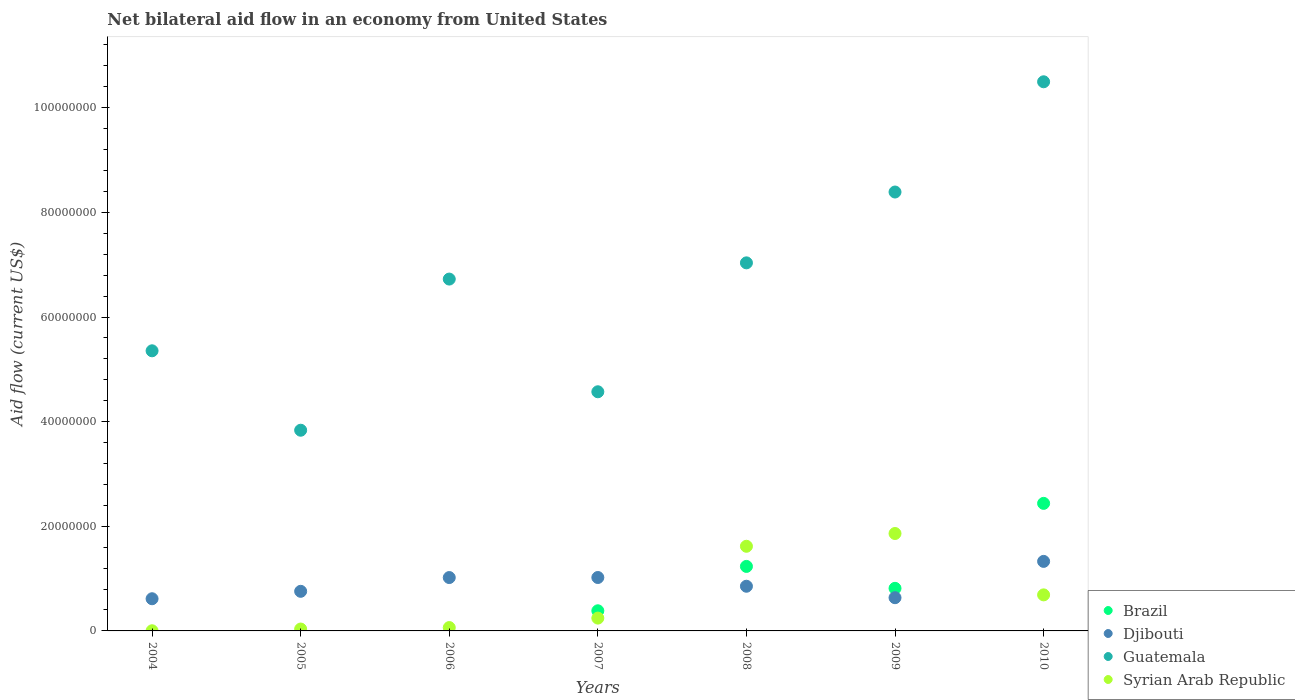Is the number of dotlines equal to the number of legend labels?
Keep it short and to the point. No. What is the net bilateral aid flow in Syrian Arab Republic in 2010?
Provide a succinct answer. 6.89e+06. Across all years, what is the maximum net bilateral aid flow in Syrian Arab Republic?
Your response must be concise. 1.86e+07. Across all years, what is the minimum net bilateral aid flow in Djibouti?
Keep it short and to the point. 6.15e+06. In which year was the net bilateral aid flow in Syrian Arab Republic maximum?
Your answer should be very brief. 2009. What is the total net bilateral aid flow in Syrian Arab Republic in the graph?
Give a very brief answer. 4.52e+07. What is the difference between the net bilateral aid flow in Djibouti in 2004 and that in 2010?
Keep it short and to the point. -7.14e+06. What is the difference between the net bilateral aid flow in Djibouti in 2006 and the net bilateral aid flow in Guatemala in 2009?
Ensure brevity in your answer.  -7.37e+07. What is the average net bilateral aid flow in Syrian Arab Republic per year?
Ensure brevity in your answer.  6.45e+06. In the year 2009, what is the difference between the net bilateral aid flow in Brazil and net bilateral aid flow in Syrian Arab Republic?
Give a very brief answer. -1.05e+07. In how many years, is the net bilateral aid flow in Syrian Arab Republic greater than 24000000 US$?
Your response must be concise. 0. What is the ratio of the net bilateral aid flow in Guatemala in 2006 to that in 2009?
Give a very brief answer. 0.8. What is the difference between the highest and the second highest net bilateral aid flow in Djibouti?
Offer a very short reply. 3.08e+06. What is the difference between the highest and the lowest net bilateral aid flow in Guatemala?
Provide a short and direct response. 6.66e+07. Is the sum of the net bilateral aid flow in Djibouti in 2006 and 2007 greater than the maximum net bilateral aid flow in Guatemala across all years?
Your answer should be very brief. No. Is it the case that in every year, the sum of the net bilateral aid flow in Guatemala and net bilateral aid flow in Syrian Arab Republic  is greater than the sum of net bilateral aid flow in Djibouti and net bilateral aid flow in Brazil?
Make the answer very short. Yes. Is it the case that in every year, the sum of the net bilateral aid flow in Djibouti and net bilateral aid flow in Brazil  is greater than the net bilateral aid flow in Guatemala?
Your response must be concise. No. Does the net bilateral aid flow in Djibouti monotonically increase over the years?
Keep it short and to the point. No. Is the net bilateral aid flow in Brazil strictly greater than the net bilateral aid flow in Djibouti over the years?
Provide a short and direct response. No. How many dotlines are there?
Keep it short and to the point. 4. Does the graph contain grids?
Make the answer very short. No. How are the legend labels stacked?
Ensure brevity in your answer.  Vertical. What is the title of the graph?
Make the answer very short. Net bilateral aid flow in an economy from United States. Does "Antigua and Barbuda" appear as one of the legend labels in the graph?
Provide a succinct answer. No. What is the Aid flow (current US$) in Djibouti in 2004?
Make the answer very short. 6.15e+06. What is the Aid flow (current US$) of Guatemala in 2004?
Provide a succinct answer. 5.35e+07. What is the Aid flow (current US$) in Djibouti in 2005?
Provide a succinct answer. 7.57e+06. What is the Aid flow (current US$) in Guatemala in 2005?
Your answer should be very brief. 3.84e+07. What is the Aid flow (current US$) in Brazil in 2006?
Ensure brevity in your answer.  0. What is the Aid flow (current US$) in Djibouti in 2006?
Your response must be concise. 1.02e+07. What is the Aid flow (current US$) in Guatemala in 2006?
Offer a very short reply. 6.72e+07. What is the Aid flow (current US$) of Syrian Arab Republic in 2006?
Provide a short and direct response. 6.40e+05. What is the Aid flow (current US$) in Brazil in 2007?
Make the answer very short. 3.85e+06. What is the Aid flow (current US$) of Djibouti in 2007?
Give a very brief answer. 1.02e+07. What is the Aid flow (current US$) in Guatemala in 2007?
Provide a succinct answer. 4.57e+07. What is the Aid flow (current US$) in Syrian Arab Republic in 2007?
Give a very brief answer. 2.45e+06. What is the Aid flow (current US$) of Brazil in 2008?
Offer a very short reply. 1.23e+07. What is the Aid flow (current US$) of Djibouti in 2008?
Your answer should be very brief. 8.54e+06. What is the Aid flow (current US$) of Guatemala in 2008?
Keep it short and to the point. 7.04e+07. What is the Aid flow (current US$) in Syrian Arab Republic in 2008?
Ensure brevity in your answer.  1.62e+07. What is the Aid flow (current US$) in Brazil in 2009?
Make the answer very short. 8.14e+06. What is the Aid flow (current US$) in Djibouti in 2009?
Keep it short and to the point. 6.35e+06. What is the Aid flow (current US$) in Guatemala in 2009?
Your answer should be very brief. 8.39e+07. What is the Aid flow (current US$) in Syrian Arab Republic in 2009?
Your answer should be compact. 1.86e+07. What is the Aid flow (current US$) in Brazil in 2010?
Give a very brief answer. 2.44e+07. What is the Aid flow (current US$) of Djibouti in 2010?
Provide a succinct answer. 1.33e+07. What is the Aid flow (current US$) in Guatemala in 2010?
Your response must be concise. 1.05e+08. What is the Aid flow (current US$) in Syrian Arab Republic in 2010?
Provide a short and direct response. 6.89e+06. Across all years, what is the maximum Aid flow (current US$) in Brazil?
Give a very brief answer. 2.44e+07. Across all years, what is the maximum Aid flow (current US$) of Djibouti?
Make the answer very short. 1.33e+07. Across all years, what is the maximum Aid flow (current US$) in Guatemala?
Provide a short and direct response. 1.05e+08. Across all years, what is the maximum Aid flow (current US$) of Syrian Arab Republic?
Your answer should be very brief. 1.86e+07. Across all years, what is the minimum Aid flow (current US$) in Brazil?
Give a very brief answer. 0. Across all years, what is the minimum Aid flow (current US$) of Djibouti?
Provide a succinct answer. 6.15e+06. Across all years, what is the minimum Aid flow (current US$) of Guatemala?
Make the answer very short. 3.84e+07. What is the total Aid flow (current US$) of Brazil in the graph?
Ensure brevity in your answer.  4.87e+07. What is the total Aid flow (current US$) of Djibouti in the graph?
Keep it short and to the point. 6.23e+07. What is the total Aid flow (current US$) in Guatemala in the graph?
Provide a succinct answer. 4.64e+08. What is the total Aid flow (current US$) in Syrian Arab Republic in the graph?
Keep it short and to the point. 4.52e+07. What is the difference between the Aid flow (current US$) in Djibouti in 2004 and that in 2005?
Your answer should be very brief. -1.42e+06. What is the difference between the Aid flow (current US$) of Guatemala in 2004 and that in 2005?
Provide a succinct answer. 1.52e+07. What is the difference between the Aid flow (current US$) in Syrian Arab Republic in 2004 and that in 2005?
Keep it short and to the point. -3.30e+05. What is the difference between the Aid flow (current US$) in Djibouti in 2004 and that in 2006?
Provide a succinct answer. -4.05e+06. What is the difference between the Aid flow (current US$) of Guatemala in 2004 and that in 2006?
Provide a short and direct response. -1.37e+07. What is the difference between the Aid flow (current US$) of Syrian Arab Republic in 2004 and that in 2006?
Give a very brief answer. -6.10e+05. What is the difference between the Aid flow (current US$) in Djibouti in 2004 and that in 2007?
Keep it short and to the point. -4.06e+06. What is the difference between the Aid flow (current US$) in Guatemala in 2004 and that in 2007?
Your answer should be compact. 7.83e+06. What is the difference between the Aid flow (current US$) in Syrian Arab Republic in 2004 and that in 2007?
Your answer should be compact. -2.42e+06. What is the difference between the Aid flow (current US$) of Djibouti in 2004 and that in 2008?
Provide a short and direct response. -2.39e+06. What is the difference between the Aid flow (current US$) in Guatemala in 2004 and that in 2008?
Ensure brevity in your answer.  -1.68e+07. What is the difference between the Aid flow (current US$) in Syrian Arab Republic in 2004 and that in 2008?
Your answer should be very brief. -1.62e+07. What is the difference between the Aid flow (current US$) in Guatemala in 2004 and that in 2009?
Ensure brevity in your answer.  -3.04e+07. What is the difference between the Aid flow (current US$) in Syrian Arab Republic in 2004 and that in 2009?
Provide a succinct answer. -1.86e+07. What is the difference between the Aid flow (current US$) of Djibouti in 2004 and that in 2010?
Your response must be concise. -7.14e+06. What is the difference between the Aid flow (current US$) in Guatemala in 2004 and that in 2010?
Ensure brevity in your answer.  -5.14e+07. What is the difference between the Aid flow (current US$) in Syrian Arab Republic in 2004 and that in 2010?
Ensure brevity in your answer.  -6.86e+06. What is the difference between the Aid flow (current US$) in Djibouti in 2005 and that in 2006?
Make the answer very short. -2.63e+06. What is the difference between the Aid flow (current US$) of Guatemala in 2005 and that in 2006?
Ensure brevity in your answer.  -2.89e+07. What is the difference between the Aid flow (current US$) of Syrian Arab Republic in 2005 and that in 2006?
Offer a terse response. -2.80e+05. What is the difference between the Aid flow (current US$) of Djibouti in 2005 and that in 2007?
Your answer should be compact. -2.64e+06. What is the difference between the Aid flow (current US$) of Guatemala in 2005 and that in 2007?
Provide a short and direct response. -7.35e+06. What is the difference between the Aid flow (current US$) in Syrian Arab Republic in 2005 and that in 2007?
Give a very brief answer. -2.09e+06. What is the difference between the Aid flow (current US$) in Djibouti in 2005 and that in 2008?
Ensure brevity in your answer.  -9.70e+05. What is the difference between the Aid flow (current US$) of Guatemala in 2005 and that in 2008?
Provide a succinct answer. -3.20e+07. What is the difference between the Aid flow (current US$) of Syrian Arab Republic in 2005 and that in 2008?
Your answer should be very brief. -1.58e+07. What is the difference between the Aid flow (current US$) in Djibouti in 2005 and that in 2009?
Provide a short and direct response. 1.22e+06. What is the difference between the Aid flow (current US$) of Guatemala in 2005 and that in 2009?
Your answer should be very brief. -4.55e+07. What is the difference between the Aid flow (current US$) in Syrian Arab Republic in 2005 and that in 2009?
Ensure brevity in your answer.  -1.83e+07. What is the difference between the Aid flow (current US$) in Djibouti in 2005 and that in 2010?
Your response must be concise. -5.72e+06. What is the difference between the Aid flow (current US$) of Guatemala in 2005 and that in 2010?
Provide a short and direct response. -6.66e+07. What is the difference between the Aid flow (current US$) in Syrian Arab Republic in 2005 and that in 2010?
Your answer should be very brief. -6.53e+06. What is the difference between the Aid flow (current US$) in Djibouti in 2006 and that in 2007?
Provide a succinct answer. -10000. What is the difference between the Aid flow (current US$) in Guatemala in 2006 and that in 2007?
Provide a short and direct response. 2.15e+07. What is the difference between the Aid flow (current US$) of Syrian Arab Republic in 2006 and that in 2007?
Your response must be concise. -1.81e+06. What is the difference between the Aid flow (current US$) of Djibouti in 2006 and that in 2008?
Provide a short and direct response. 1.66e+06. What is the difference between the Aid flow (current US$) in Guatemala in 2006 and that in 2008?
Offer a very short reply. -3.10e+06. What is the difference between the Aid flow (current US$) of Syrian Arab Republic in 2006 and that in 2008?
Offer a very short reply. -1.55e+07. What is the difference between the Aid flow (current US$) of Djibouti in 2006 and that in 2009?
Your answer should be compact. 3.85e+06. What is the difference between the Aid flow (current US$) in Guatemala in 2006 and that in 2009?
Keep it short and to the point. -1.66e+07. What is the difference between the Aid flow (current US$) of Syrian Arab Republic in 2006 and that in 2009?
Make the answer very short. -1.80e+07. What is the difference between the Aid flow (current US$) in Djibouti in 2006 and that in 2010?
Give a very brief answer. -3.09e+06. What is the difference between the Aid flow (current US$) in Guatemala in 2006 and that in 2010?
Your response must be concise. -3.77e+07. What is the difference between the Aid flow (current US$) in Syrian Arab Republic in 2006 and that in 2010?
Your response must be concise. -6.25e+06. What is the difference between the Aid flow (current US$) of Brazil in 2007 and that in 2008?
Provide a succinct answer. -8.48e+06. What is the difference between the Aid flow (current US$) of Djibouti in 2007 and that in 2008?
Your answer should be compact. 1.67e+06. What is the difference between the Aid flow (current US$) in Guatemala in 2007 and that in 2008?
Your response must be concise. -2.46e+07. What is the difference between the Aid flow (current US$) of Syrian Arab Republic in 2007 and that in 2008?
Give a very brief answer. -1.37e+07. What is the difference between the Aid flow (current US$) in Brazil in 2007 and that in 2009?
Offer a terse response. -4.29e+06. What is the difference between the Aid flow (current US$) in Djibouti in 2007 and that in 2009?
Give a very brief answer. 3.86e+06. What is the difference between the Aid flow (current US$) in Guatemala in 2007 and that in 2009?
Make the answer very short. -3.82e+07. What is the difference between the Aid flow (current US$) in Syrian Arab Republic in 2007 and that in 2009?
Offer a very short reply. -1.62e+07. What is the difference between the Aid flow (current US$) of Brazil in 2007 and that in 2010?
Ensure brevity in your answer.  -2.05e+07. What is the difference between the Aid flow (current US$) of Djibouti in 2007 and that in 2010?
Your response must be concise. -3.08e+06. What is the difference between the Aid flow (current US$) in Guatemala in 2007 and that in 2010?
Ensure brevity in your answer.  -5.92e+07. What is the difference between the Aid flow (current US$) of Syrian Arab Republic in 2007 and that in 2010?
Ensure brevity in your answer.  -4.44e+06. What is the difference between the Aid flow (current US$) in Brazil in 2008 and that in 2009?
Offer a terse response. 4.19e+06. What is the difference between the Aid flow (current US$) in Djibouti in 2008 and that in 2009?
Provide a succinct answer. 2.19e+06. What is the difference between the Aid flow (current US$) of Guatemala in 2008 and that in 2009?
Ensure brevity in your answer.  -1.35e+07. What is the difference between the Aid flow (current US$) of Syrian Arab Republic in 2008 and that in 2009?
Offer a very short reply. -2.44e+06. What is the difference between the Aid flow (current US$) in Brazil in 2008 and that in 2010?
Your response must be concise. -1.20e+07. What is the difference between the Aid flow (current US$) in Djibouti in 2008 and that in 2010?
Your response must be concise. -4.75e+06. What is the difference between the Aid flow (current US$) of Guatemala in 2008 and that in 2010?
Your response must be concise. -3.46e+07. What is the difference between the Aid flow (current US$) of Syrian Arab Republic in 2008 and that in 2010?
Make the answer very short. 9.29e+06. What is the difference between the Aid flow (current US$) in Brazil in 2009 and that in 2010?
Offer a terse response. -1.62e+07. What is the difference between the Aid flow (current US$) of Djibouti in 2009 and that in 2010?
Offer a very short reply. -6.94e+06. What is the difference between the Aid flow (current US$) of Guatemala in 2009 and that in 2010?
Your response must be concise. -2.11e+07. What is the difference between the Aid flow (current US$) in Syrian Arab Republic in 2009 and that in 2010?
Give a very brief answer. 1.17e+07. What is the difference between the Aid flow (current US$) in Djibouti in 2004 and the Aid flow (current US$) in Guatemala in 2005?
Offer a terse response. -3.22e+07. What is the difference between the Aid flow (current US$) in Djibouti in 2004 and the Aid flow (current US$) in Syrian Arab Republic in 2005?
Provide a succinct answer. 5.79e+06. What is the difference between the Aid flow (current US$) in Guatemala in 2004 and the Aid flow (current US$) in Syrian Arab Republic in 2005?
Your answer should be very brief. 5.32e+07. What is the difference between the Aid flow (current US$) in Djibouti in 2004 and the Aid flow (current US$) in Guatemala in 2006?
Make the answer very short. -6.11e+07. What is the difference between the Aid flow (current US$) of Djibouti in 2004 and the Aid flow (current US$) of Syrian Arab Republic in 2006?
Keep it short and to the point. 5.51e+06. What is the difference between the Aid flow (current US$) of Guatemala in 2004 and the Aid flow (current US$) of Syrian Arab Republic in 2006?
Provide a succinct answer. 5.29e+07. What is the difference between the Aid flow (current US$) in Djibouti in 2004 and the Aid flow (current US$) in Guatemala in 2007?
Give a very brief answer. -3.96e+07. What is the difference between the Aid flow (current US$) of Djibouti in 2004 and the Aid flow (current US$) of Syrian Arab Republic in 2007?
Provide a short and direct response. 3.70e+06. What is the difference between the Aid flow (current US$) in Guatemala in 2004 and the Aid flow (current US$) in Syrian Arab Republic in 2007?
Provide a succinct answer. 5.11e+07. What is the difference between the Aid flow (current US$) of Djibouti in 2004 and the Aid flow (current US$) of Guatemala in 2008?
Keep it short and to the point. -6.42e+07. What is the difference between the Aid flow (current US$) of Djibouti in 2004 and the Aid flow (current US$) of Syrian Arab Republic in 2008?
Offer a very short reply. -1.00e+07. What is the difference between the Aid flow (current US$) of Guatemala in 2004 and the Aid flow (current US$) of Syrian Arab Republic in 2008?
Offer a very short reply. 3.74e+07. What is the difference between the Aid flow (current US$) in Djibouti in 2004 and the Aid flow (current US$) in Guatemala in 2009?
Your answer should be compact. -7.77e+07. What is the difference between the Aid flow (current US$) in Djibouti in 2004 and the Aid flow (current US$) in Syrian Arab Republic in 2009?
Your response must be concise. -1.25e+07. What is the difference between the Aid flow (current US$) in Guatemala in 2004 and the Aid flow (current US$) in Syrian Arab Republic in 2009?
Provide a short and direct response. 3.49e+07. What is the difference between the Aid flow (current US$) of Djibouti in 2004 and the Aid flow (current US$) of Guatemala in 2010?
Ensure brevity in your answer.  -9.88e+07. What is the difference between the Aid flow (current US$) of Djibouti in 2004 and the Aid flow (current US$) of Syrian Arab Republic in 2010?
Keep it short and to the point. -7.40e+05. What is the difference between the Aid flow (current US$) of Guatemala in 2004 and the Aid flow (current US$) of Syrian Arab Republic in 2010?
Provide a succinct answer. 4.66e+07. What is the difference between the Aid flow (current US$) in Djibouti in 2005 and the Aid flow (current US$) in Guatemala in 2006?
Give a very brief answer. -5.97e+07. What is the difference between the Aid flow (current US$) of Djibouti in 2005 and the Aid flow (current US$) of Syrian Arab Republic in 2006?
Offer a very short reply. 6.93e+06. What is the difference between the Aid flow (current US$) in Guatemala in 2005 and the Aid flow (current US$) in Syrian Arab Republic in 2006?
Ensure brevity in your answer.  3.77e+07. What is the difference between the Aid flow (current US$) in Djibouti in 2005 and the Aid flow (current US$) in Guatemala in 2007?
Provide a short and direct response. -3.81e+07. What is the difference between the Aid flow (current US$) in Djibouti in 2005 and the Aid flow (current US$) in Syrian Arab Republic in 2007?
Ensure brevity in your answer.  5.12e+06. What is the difference between the Aid flow (current US$) in Guatemala in 2005 and the Aid flow (current US$) in Syrian Arab Republic in 2007?
Ensure brevity in your answer.  3.59e+07. What is the difference between the Aid flow (current US$) of Djibouti in 2005 and the Aid flow (current US$) of Guatemala in 2008?
Keep it short and to the point. -6.28e+07. What is the difference between the Aid flow (current US$) in Djibouti in 2005 and the Aid flow (current US$) in Syrian Arab Republic in 2008?
Offer a terse response. -8.61e+06. What is the difference between the Aid flow (current US$) of Guatemala in 2005 and the Aid flow (current US$) of Syrian Arab Republic in 2008?
Offer a terse response. 2.22e+07. What is the difference between the Aid flow (current US$) in Djibouti in 2005 and the Aid flow (current US$) in Guatemala in 2009?
Offer a terse response. -7.63e+07. What is the difference between the Aid flow (current US$) in Djibouti in 2005 and the Aid flow (current US$) in Syrian Arab Republic in 2009?
Your answer should be compact. -1.10e+07. What is the difference between the Aid flow (current US$) in Guatemala in 2005 and the Aid flow (current US$) in Syrian Arab Republic in 2009?
Offer a very short reply. 1.97e+07. What is the difference between the Aid flow (current US$) of Djibouti in 2005 and the Aid flow (current US$) of Guatemala in 2010?
Give a very brief answer. -9.74e+07. What is the difference between the Aid flow (current US$) in Djibouti in 2005 and the Aid flow (current US$) in Syrian Arab Republic in 2010?
Keep it short and to the point. 6.80e+05. What is the difference between the Aid flow (current US$) of Guatemala in 2005 and the Aid flow (current US$) of Syrian Arab Republic in 2010?
Provide a succinct answer. 3.15e+07. What is the difference between the Aid flow (current US$) in Djibouti in 2006 and the Aid flow (current US$) in Guatemala in 2007?
Your response must be concise. -3.55e+07. What is the difference between the Aid flow (current US$) in Djibouti in 2006 and the Aid flow (current US$) in Syrian Arab Republic in 2007?
Your answer should be compact. 7.75e+06. What is the difference between the Aid flow (current US$) of Guatemala in 2006 and the Aid flow (current US$) of Syrian Arab Republic in 2007?
Ensure brevity in your answer.  6.48e+07. What is the difference between the Aid flow (current US$) of Djibouti in 2006 and the Aid flow (current US$) of Guatemala in 2008?
Make the answer very short. -6.02e+07. What is the difference between the Aid flow (current US$) in Djibouti in 2006 and the Aid flow (current US$) in Syrian Arab Republic in 2008?
Your answer should be very brief. -5.98e+06. What is the difference between the Aid flow (current US$) in Guatemala in 2006 and the Aid flow (current US$) in Syrian Arab Republic in 2008?
Ensure brevity in your answer.  5.11e+07. What is the difference between the Aid flow (current US$) of Djibouti in 2006 and the Aid flow (current US$) of Guatemala in 2009?
Offer a very short reply. -7.37e+07. What is the difference between the Aid flow (current US$) of Djibouti in 2006 and the Aid flow (current US$) of Syrian Arab Republic in 2009?
Make the answer very short. -8.42e+06. What is the difference between the Aid flow (current US$) of Guatemala in 2006 and the Aid flow (current US$) of Syrian Arab Republic in 2009?
Keep it short and to the point. 4.86e+07. What is the difference between the Aid flow (current US$) in Djibouti in 2006 and the Aid flow (current US$) in Guatemala in 2010?
Provide a short and direct response. -9.48e+07. What is the difference between the Aid flow (current US$) in Djibouti in 2006 and the Aid flow (current US$) in Syrian Arab Republic in 2010?
Provide a succinct answer. 3.31e+06. What is the difference between the Aid flow (current US$) of Guatemala in 2006 and the Aid flow (current US$) of Syrian Arab Republic in 2010?
Give a very brief answer. 6.04e+07. What is the difference between the Aid flow (current US$) of Brazil in 2007 and the Aid flow (current US$) of Djibouti in 2008?
Your answer should be compact. -4.69e+06. What is the difference between the Aid flow (current US$) of Brazil in 2007 and the Aid flow (current US$) of Guatemala in 2008?
Make the answer very short. -6.65e+07. What is the difference between the Aid flow (current US$) in Brazil in 2007 and the Aid flow (current US$) in Syrian Arab Republic in 2008?
Offer a very short reply. -1.23e+07. What is the difference between the Aid flow (current US$) in Djibouti in 2007 and the Aid flow (current US$) in Guatemala in 2008?
Your answer should be compact. -6.01e+07. What is the difference between the Aid flow (current US$) of Djibouti in 2007 and the Aid flow (current US$) of Syrian Arab Republic in 2008?
Make the answer very short. -5.97e+06. What is the difference between the Aid flow (current US$) in Guatemala in 2007 and the Aid flow (current US$) in Syrian Arab Republic in 2008?
Ensure brevity in your answer.  2.95e+07. What is the difference between the Aid flow (current US$) in Brazil in 2007 and the Aid flow (current US$) in Djibouti in 2009?
Provide a short and direct response. -2.50e+06. What is the difference between the Aid flow (current US$) in Brazil in 2007 and the Aid flow (current US$) in Guatemala in 2009?
Give a very brief answer. -8.00e+07. What is the difference between the Aid flow (current US$) in Brazil in 2007 and the Aid flow (current US$) in Syrian Arab Republic in 2009?
Your answer should be compact. -1.48e+07. What is the difference between the Aid flow (current US$) of Djibouti in 2007 and the Aid flow (current US$) of Guatemala in 2009?
Your answer should be compact. -7.37e+07. What is the difference between the Aid flow (current US$) in Djibouti in 2007 and the Aid flow (current US$) in Syrian Arab Republic in 2009?
Offer a terse response. -8.41e+06. What is the difference between the Aid flow (current US$) of Guatemala in 2007 and the Aid flow (current US$) of Syrian Arab Republic in 2009?
Offer a terse response. 2.71e+07. What is the difference between the Aid flow (current US$) of Brazil in 2007 and the Aid flow (current US$) of Djibouti in 2010?
Ensure brevity in your answer.  -9.44e+06. What is the difference between the Aid flow (current US$) in Brazil in 2007 and the Aid flow (current US$) in Guatemala in 2010?
Your answer should be compact. -1.01e+08. What is the difference between the Aid flow (current US$) of Brazil in 2007 and the Aid flow (current US$) of Syrian Arab Republic in 2010?
Your answer should be very brief. -3.04e+06. What is the difference between the Aid flow (current US$) in Djibouti in 2007 and the Aid flow (current US$) in Guatemala in 2010?
Your answer should be very brief. -9.48e+07. What is the difference between the Aid flow (current US$) of Djibouti in 2007 and the Aid flow (current US$) of Syrian Arab Republic in 2010?
Make the answer very short. 3.32e+06. What is the difference between the Aid flow (current US$) of Guatemala in 2007 and the Aid flow (current US$) of Syrian Arab Republic in 2010?
Offer a very short reply. 3.88e+07. What is the difference between the Aid flow (current US$) in Brazil in 2008 and the Aid flow (current US$) in Djibouti in 2009?
Keep it short and to the point. 5.98e+06. What is the difference between the Aid flow (current US$) in Brazil in 2008 and the Aid flow (current US$) in Guatemala in 2009?
Offer a terse response. -7.16e+07. What is the difference between the Aid flow (current US$) of Brazil in 2008 and the Aid flow (current US$) of Syrian Arab Republic in 2009?
Keep it short and to the point. -6.29e+06. What is the difference between the Aid flow (current US$) in Djibouti in 2008 and the Aid flow (current US$) in Guatemala in 2009?
Ensure brevity in your answer.  -7.54e+07. What is the difference between the Aid flow (current US$) in Djibouti in 2008 and the Aid flow (current US$) in Syrian Arab Republic in 2009?
Give a very brief answer. -1.01e+07. What is the difference between the Aid flow (current US$) of Guatemala in 2008 and the Aid flow (current US$) of Syrian Arab Republic in 2009?
Keep it short and to the point. 5.17e+07. What is the difference between the Aid flow (current US$) of Brazil in 2008 and the Aid flow (current US$) of Djibouti in 2010?
Your response must be concise. -9.60e+05. What is the difference between the Aid flow (current US$) of Brazil in 2008 and the Aid flow (current US$) of Guatemala in 2010?
Provide a succinct answer. -9.26e+07. What is the difference between the Aid flow (current US$) of Brazil in 2008 and the Aid flow (current US$) of Syrian Arab Republic in 2010?
Make the answer very short. 5.44e+06. What is the difference between the Aid flow (current US$) in Djibouti in 2008 and the Aid flow (current US$) in Guatemala in 2010?
Keep it short and to the point. -9.64e+07. What is the difference between the Aid flow (current US$) of Djibouti in 2008 and the Aid flow (current US$) of Syrian Arab Republic in 2010?
Your answer should be compact. 1.65e+06. What is the difference between the Aid flow (current US$) of Guatemala in 2008 and the Aid flow (current US$) of Syrian Arab Republic in 2010?
Provide a succinct answer. 6.35e+07. What is the difference between the Aid flow (current US$) of Brazil in 2009 and the Aid flow (current US$) of Djibouti in 2010?
Offer a terse response. -5.15e+06. What is the difference between the Aid flow (current US$) in Brazil in 2009 and the Aid flow (current US$) in Guatemala in 2010?
Give a very brief answer. -9.68e+07. What is the difference between the Aid flow (current US$) in Brazil in 2009 and the Aid flow (current US$) in Syrian Arab Republic in 2010?
Give a very brief answer. 1.25e+06. What is the difference between the Aid flow (current US$) in Djibouti in 2009 and the Aid flow (current US$) in Guatemala in 2010?
Your response must be concise. -9.86e+07. What is the difference between the Aid flow (current US$) of Djibouti in 2009 and the Aid flow (current US$) of Syrian Arab Republic in 2010?
Make the answer very short. -5.40e+05. What is the difference between the Aid flow (current US$) in Guatemala in 2009 and the Aid flow (current US$) in Syrian Arab Republic in 2010?
Give a very brief answer. 7.70e+07. What is the average Aid flow (current US$) in Brazil per year?
Your answer should be compact. 6.96e+06. What is the average Aid flow (current US$) of Djibouti per year?
Give a very brief answer. 8.90e+06. What is the average Aid flow (current US$) of Guatemala per year?
Provide a short and direct response. 6.63e+07. What is the average Aid flow (current US$) in Syrian Arab Republic per year?
Give a very brief answer. 6.45e+06. In the year 2004, what is the difference between the Aid flow (current US$) in Djibouti and Aid flow (current US$) in Guatemala?
Ensure brevity in your answer.  -4.74e+07. In the year 2004, what is the difference between the Aid flow (current US$) of Djibouti and Aid flow (current US$) of Syrian Arab Republic?
Offer a very short reply. 6.12e+06. In the year 2004, what is the difference between the Aid flow (current US$) of Guatemala and Aid flow (current US$) of Syrian Arab Republic?
Offer a terse response. 5.35e+07. In the year 2005, what is the difference between the Aid flow (current US$) of Djibouti and Aid flow (current US$) of Guatemala?
Ensure brevity in your answer.  -3.08e+07. In the year 2005, what is the difference between the Aid flow (current US$) of Djibouti and Aid flow (current US$) of Syrian Arab Republic?
Your answer should be very brief. 7.21e+06. In the year 2005, what is the difference between the Aid flow (current US$) in Guatemala and Aid flow (current US$) in Syrian Arab Republic?
Make the answer very short. 3.80e+07. In the year 2006, what is the difference between the Aid flow (current US$) of Djibouti and Aid flow (current US$) of Guatemala?
Your answer should be compact. -5.70e+07. In the year 2006, what is the difference between the Aid flow (current US$) in Djibouti and Aid flow (current US$) in Syrian Arab Republic?
Give a very brief answer. 9.56e+06. In the year 2006, what is the difference between the Aid flow (current US$) in Guatemala and Aid flow (current US$) in Syrian Arab Republic?
Provide a short and direct response. 6.66e+07. In the year 2007, what is the difference between the Aid flow (current US$) of Brazil and Aid flow (current US$) of Djibouti?
Offer a terse response. -6.36e+06. In the year 2007, what is the difference between the Aid flow (current US$) in Brazil and Aid flow (current US$) in Guatemala?
Provide a succinct answer. -4.19e+07. In the year 2007, what is the difference between the Aid flow (current US$) in Brazil and Aid flow (current US$) in Syrian Arab Republic?
Your answer should be compact. 1.40e+06. In the year 2007, what is the difference between the Aid flow (current US$) in Djibouti and Aid flow (current US$) in Guatemala?
Provide a succinct answer. -3.55e+07. In the year 2007, what is the difference between the Aid flow (current US$) of Djibouti and Aid flow (current US$) of Syrian Arab Republic?
Your answer should be compact. 7.76e+06. In the year 2007, what is the difference between the Aid flow (current US$) of Guatemala and Aid flow (current US$) of Syrian Arab Republic?
Ensure brevity in your answer.  4.33e+07. In the year 2008, what is the difference between the Aid flow (current US$) of Brazil and Aid flow (current US$) of Djibouti?
Your response must be concise. 3.79e+06. In the year 2008, what is the difference between the Aid flow (current US$) in Brazil and Aid flow (current US$) in Guatemala?
Give a very brief answer. -5.80e+07. In the year 2008, what is the difference between the Aid flow (current US$) of Brazil and Aid flow (current US$) of Syrian Arab Republic?
Your answer should be compact. -3.85e+06. In the year 2008, what is the difference between the Aid flow (current US$) in Djibouti and Aid flow (current US$) in Guatemala?
Your answer should be very brief. -6.18e+07. In the year 2008, what is the difference between the Aid flow (current US$) of Djibouti and Aid flow (current US$) of Syrian Arab Republic?
Offer a terse response. -7.64e+06. In the year 2008, what is the difference between the Aid flow (current US$) in Guatemala and Aid flow (current US$) in Syrian Arab Republic?
Give a very brief answer. 5.42e+07. In the year 2009, what is the difference between the Aid flow (current US$) of Brazil and Aid flow (current US$) of Djibouti?
Your answer should be very brief. 1.79e+06. In the year 2009, what is the difference between the Aid flow (current US$) in Brazil and Aid flow (current US$) in Guatemala?
Your answer should be compact. -7.58e+07. In the year 2009, what is the difference between the Aid flow (current US$) in Brazil and Aid flow (current US$) in Syrian Arab Republic?
Offer a very short reply. -1.05e+07. In the year 2009, what is the difference between the Aid flow (current US$) in Djibouti and Aid flow (current US$) in Guatemala?
Your response must be concise. -7.75e+07. In the year 2009, what is the difference between the Aid flow (current US$) in Djibouti and Aid flow (current US$) in Syrian Arab Republic?
Make the answer very short. -1.23e+07. In the year 2009, what is the difference between the Aid flow (current US$) in Guatemala and Aid flow (current US$) in Syrian Arab Republic?
Make the answer very short. 6.53e+07. In the year 2010, what is the difference between the Aid flow (current US$) of Brazil and Aid flow (current US$) of Djibouti?
Your response must be concise. 1.11e+07. In the year 2010, what is the difference between the Aid flow (current US$) in Brazil and Aid flow (current US$) in Guatemala?
Make the answer very short. -8.06e+07. In the year 2010, what is the difference between the Aid flow (current US$) of Brazil and Aid flow (current US$) of Syrian Arab Republic?
Keep it short and to the point. 1.75e+07. In the year 2010, what is the difference between the Aid flow (current US$) of Djibouti and Aid flow (current US$) of Guatemala?
Give a very brief answer. -9.17e+07. In the year 2010, what is the difference between the Aid flow (current US$) in Djibouti and Aid flow (current US$) in Syrian Arab Republic?
Offer a terse response. 6.40e+06. In the year 2010, what is the difference between the Aid flow (current US$) of Guatemala and Aid flow (current US$) of Syrian Arab Republic?
Offer a terse response. 9.81e+07. What is the ratio of the Aid flow (current US$) in Djibouti in 2004 to that in 2005?
Keep it short and to the point. 0.81. What is the ratio of the Aid flow (current US$) of Guatemala in 2004 to that in 2005?
Your answer should be compact. 1.4. What is the ratio of the Aid flow (current US$) in Syrian Arab Republic in 2004 to that in 2005?
Make the answer very short. 0.08. What is the ratio of the Aid flow (current US$) of Djibouti in 2004 to that in 2006?
Offer a very short reply. 0.6. What is the ratio of the Aid flow (current US$) of Guatemala in 2004 to that in 2006?
Give a very brief answer. 0.8. What is the ratio of the Aid flow (current US$) in Syrian Arab Republic in 2004 to that in 2006?
Ensure brevity in your answer.  0.05. What is the ratio of the Aid flow (current US$) of Djibouti in 2004 to that in 2007?
Offer a terse response. 0.6. What is the ratio of the Aid flow (current US$) in Guatemala in 2004 to that in 2007?
Make the answer very short. 1.17. What is the ratio of the Aid flow (current US$) in Syrian Arab Republic in 2004 to that in 2007?
Offer a very short reply. 0.01. What is the ratio of the Aid flow (current US$) of Djibouti in 2004 to that in 2008?
Ensure brevity in your answer.  0.72. What is the ratio of the Aid flow (current US$) in Guatemala in 2004 to that in 2008?
Make the answer very short. 0.76. What is the ratio of the Aid flow (current US$) in Syrian Arab Republic in 2004 to that in 2008?
Your response must be concise. 0. What is the ratio of the Aid flow (current US$) of Djibouti in 2004 to that in 2009?
Provide a short and direct response. 0.97. What is the ratio of the Aid flow (current US$) of Guatemala in 2004 to that in 2009?
Offer a very short reply. 0.64. What is the ratio of the Aid flow (current US$) in Syrian Arab Republic in 2004 to that in 2009?
Your answer should be very brief. 0. What is the ratio of the Aid flow (current US$) in Djibouti in 2004 to that in 2010?
Your answer should be very brief. 0.46. What is the ratio of the Aid flow (current US$) in Guatemala in 2004 to that in 2010?
Your response must be concise. 0.51. What is the ratio of the Aid flow (current US$) in Syrian Arab Republic in 2004 to that in 2010?
Your answer should be very brief. 0. What is the ratio of the Aid flow (current US$) of Djibouti in 2005 to that in 2006?
Your answer should be compact. 0.74. What is the ratio of the Aid flow (current US$) in Guatemala in 2005 to that in 2006?
Make the answer very short. 0.57. What is the ratio of the Aid flow (current US$) of Syrian Arab Republic in 2005 to that in 2006?
Ensure brevity in your answer.  0.56. What is the ratio of the Aid flow (current US$) in Djibouti in 2005 to that in 2007?
Your answer should be very brief. 0.74. What is the ratio of the Aid flow (current US$) of Guatemala in 2005 to that in 2007?
Your response must be concise. 0.84. What is the ratio of the Aid flow (current US$) of Syrian Arab Republic in 2005 to that in 2007?
Provide a short and direct response. 0.15. What is the ratio of the Aid flow (current US$) in Djibouti in 2005 to that in 2008?
Offer a terse response. 0.89. What is the ratio of the Aid flow (current US$) in Guatemala in 2005 to that in 2008?
Keep it short and to the point. 0.55. What is the ratio of the Aid flow (current US$) of Syrian Arab Republic in 2005 to that in 2008?
Your response must be concise. 0.02. What is the ratio of the Aid flow (current US$) of Djibouti in 2005 to that in 2009?
Your answer should be compact. 1.19. What is the ratio of the Aid flow (current US$) in Guatemala in 2005 to that in 2009?
Provide a short and direct response. 0.46. What is the ratio of the Aid flow (current US$) of Syrian Arab Republic in 2005 to that in 2009?
Your answer should be compact. 0.02. What is the ratio of the Aid flow (current US$) of Djibouti in 2005 to that in 2010?
Your answer should be very brief. 0.57. What is the ratio of the Aid flow (current US$) of Guatemala in 2005 to that in 2010?
Offer a very short reply. 0.37. What is the ratio of the Aid flow (current US$) in Syrian Arab Republic in 2005 to that in 2010?
Make the answer very short. 0.05. What is the ratio of the Aid flow (current US$) of Djibouti in 2006 to that in 2007?
Make the answer very short. 1. What is the ratio of the Aid flow (current US$) in Guatemala in 2006 to that in 2007?
Your answer should be very brief. 1.47. What is the ratio of the Aid flow (current US$) of Syrian Arab Republic in 2006 to that in 2007?
Offer a very short reply. 0.26. What is the ratio of the Aid flow (current US$) of Djibouti in 2006 to that in 2008?
Offer a very short reply. 1.19. What is the ratio of the Aid flow (current US$) in Guatemala in 2006 to that in 2008?
Offer a terse response. 0.96. What is the ratio of the Aid flow (current US$) in Syrian Arab Republic in 2006 to that in 2008?
Provide a succinct answer. 0.04. What is the ratio of the Aid flow (current US$) in Djibouti in 2006 to that in 2009?
Make the answer very short. 1.61. What is the ratio of the Aid flow (current US$) in Guatemala in 2006 to that in 2009?
Offer a very short reply. 0.8. What is the ratio of the Aid flow (current US$) in Syrian Arab Republic in 2006 to that in 2009?
Your answer should be very brief. 0.03. What is the ratio of the Aid flow (current US$) in Djibouti in 2006 to that in 2010?
Your answer should be very brief. 0.77. What is the ratio of the Aid flow (current US$) in Guatemala in 2006 to that in 2010?
Keep it short and to the point. 0.64. What is the ratio of the Aid flow (current US$) in Syrian Arab Republic in 2006 to that in 2010?
Your answer should be very brief. 0.09. What is the ratio of the Aid flow (current US$) of Brazil in 2007 to that in 2008?
Offer a very short reply. 0.31. What is the ratio of the Aid flow (current US$) in Djibouti in 2007 to that in 2008?
Make the answer very short. 1.2. What is the ratio of the Aid flow (current US$) of Guatemala in 2007 to that in 2008?
Your response must be concise. 0.65. What is the ratio of the Aid flow (current US$) in Syrian Arab Republic in 2007 to that in 2008?
Provide a succinct answer. 0.15. What is the ratio of the Aid flow (current US$) of Brazil in 2007 to that in 2009?
Your answer should be compact. 0.47. What is the ratio of the Aid flow (current US$) in Djibouti in 2007 to that in 2009?
Offer a terse response. 1.61. What is the ratio of the Aid flow (current US$) in Guatemala in 2007 to that in 2009?
Provide a short and direct response. 0.54. What is the ratio of the Aid flow (current US$) of Syrian Arab Republic in 2007 to that in 2009?
Keep it short and to the point. 0.13. What is the ratio of the Aid flow (current US$) of Brazil in 2007 to that in 2010?
Give a very brief answer. 0.16. What is the ratio of the Aid flow (current US$) of Djibouti in 2007 to that in 2010?
Keep it short and to the point. 0.77. What is the ratio of the Aid flow (current US$) of Guatemala in 2007 to that in 2010?
Provide a short and direct response. 0.44. What is the ratio of the Aid flow (current US$) in Syrian Arab Republic in 2007 to that in 2010?
Your response must be concise. 0.36. What is the ratio of the Aid flow (current US$) in Brazil in 2008 to that in 2009?
Your answer should be compact. 1.51. What is the ratio of the Aid flow (current US$) of Djibouti in 2008 to that in 2009?
Give a very brief answer. 1.34. What is the ratio of the Aid flow (current US$) of Guatemala in 2008 to that in 2009?
Keep it short and to the point. 0.84. What is the ratio of the Aid flow (current US$) of Syrian Arab Republic in 2008 to that in 2009?
Your answer should be very brief. 0.87. What is the ratio of the Aid flow (current US$) of Brazil in 2008 to that in 2010?
Keep it short and to the point. 0.51. What is the ratio of the Aid flow (current US$) of Djibouti in 2008 to that in 2010?
Make the answer very short. 0.64. What is the ratio of the Aid flow (current US$) in Guatemala in 2008 to that in 2010?
Offer a very short reply. 0.67. What is the ratio of the Aid flow (current US$) in Syrian Arab Republic in 2008 to that in 2010?
Make the answer very short. 2.35. What is the ratio of the Aid flow (current US$) of Brazil in 2009 to that in 2010?
Offer a terse response. 0.33. What is the ratio of the Aid flow (current US$) of Djibouti in 2009 to that in 2010?
Your answer should be very brief. 0.48. What is the ratio of the Aid flow (current US$) in Guatemala in 2009 to that in 2010?
Make the answer very short. 0.8. What is the ratio of the Aid flow (current US$) of Syrian Arab Republic in 2009 to that in 2010?
Provide a succinct answer. 2.7. What is the difference between the highest and the second highest Aid flow (current US$) in Brazil?
Ensure brevity in your answer.  1.20e+07. What is the difference between the highest and the second highest Aid flow (current US$) in Djibouti?
Ensure brevity in your answer.  3.08e+06. What is the difference between the highest and the second highest Aid flow (current US$) of Guatemala?
Make the answer very short. 2.11e+07. What is the difference between the highest and the second highest Aid flow (current US$) of Syrian Arab Republic?
Keep it short and to the point. 2.44e+06. What is the difference between the highest and the lowest Aid flow (current US$) of Brazil?
Provide a short and direct response. 2.44e+07. What is the difference between the highest and the lowest Aid flow (current US$) of Djibouti?
Your answer should be very brief. 7.14e+06. What is the difference between the highest and the lowest Aid flow (current US$) in Guatemala?
Your response must be concise. 6.66e+07. What is the difference between the highest and the lowest Aid flow (current US$) in Syrian Arab Republic?
Offer a terse response. 1.86e+07. 